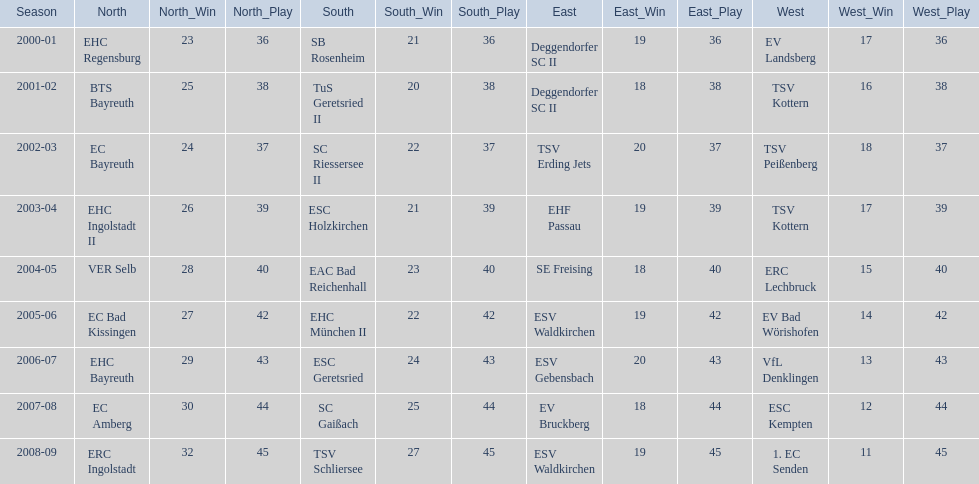Which teams played in the north? EHC Regensburg, BTS Bayreuth, EC Bayreuth, EHC Ingolstadt II, VER Selb, EC Bad Kissingen, EHC Bayreuth, EC Amberg, ERC Ingolstadt. Of these teams, which played during 2000-2001? EHC Regensburg. 